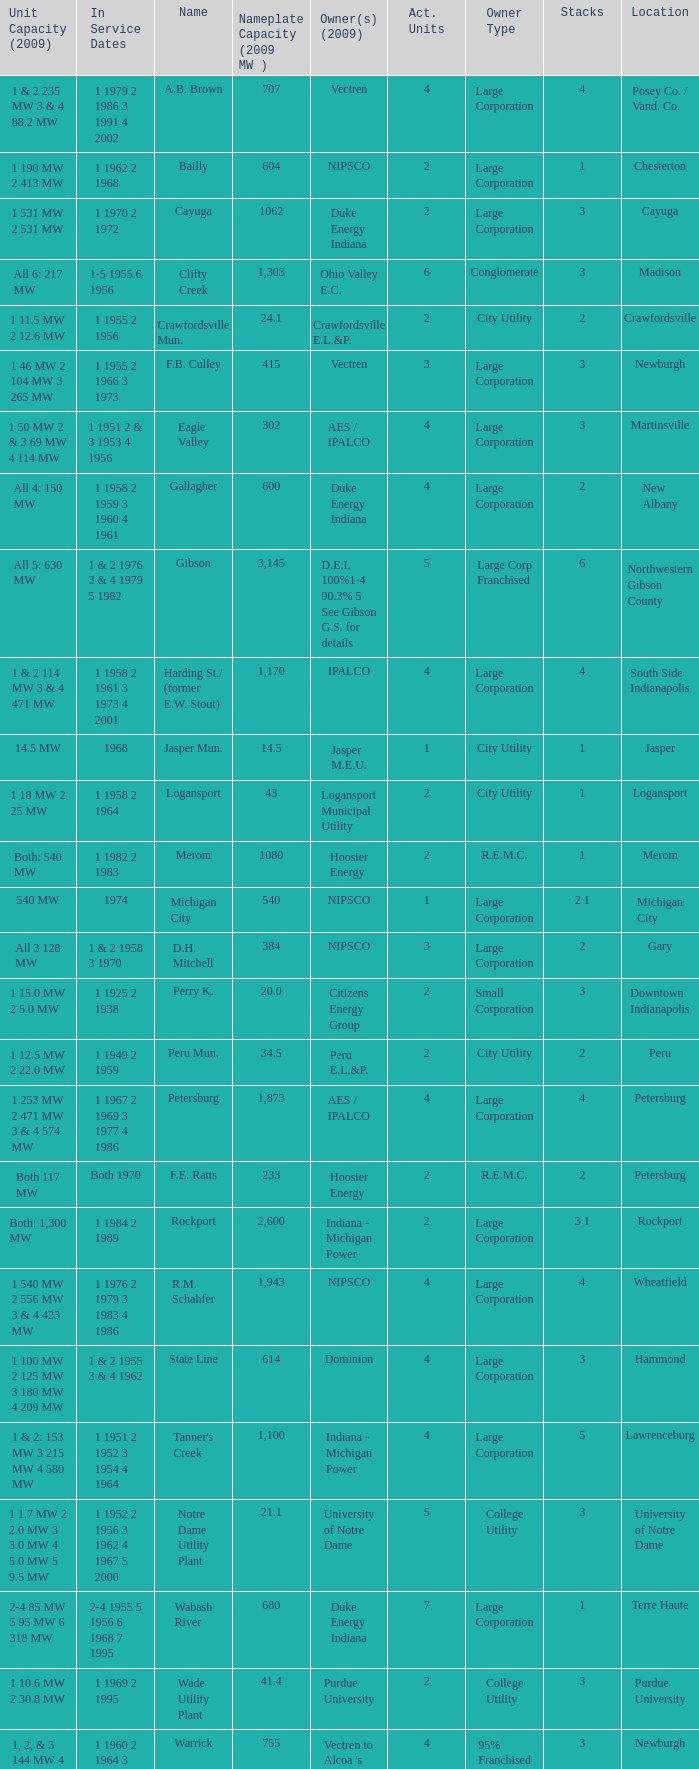Name the stacks for 1 1969 2 1995 3.0. 